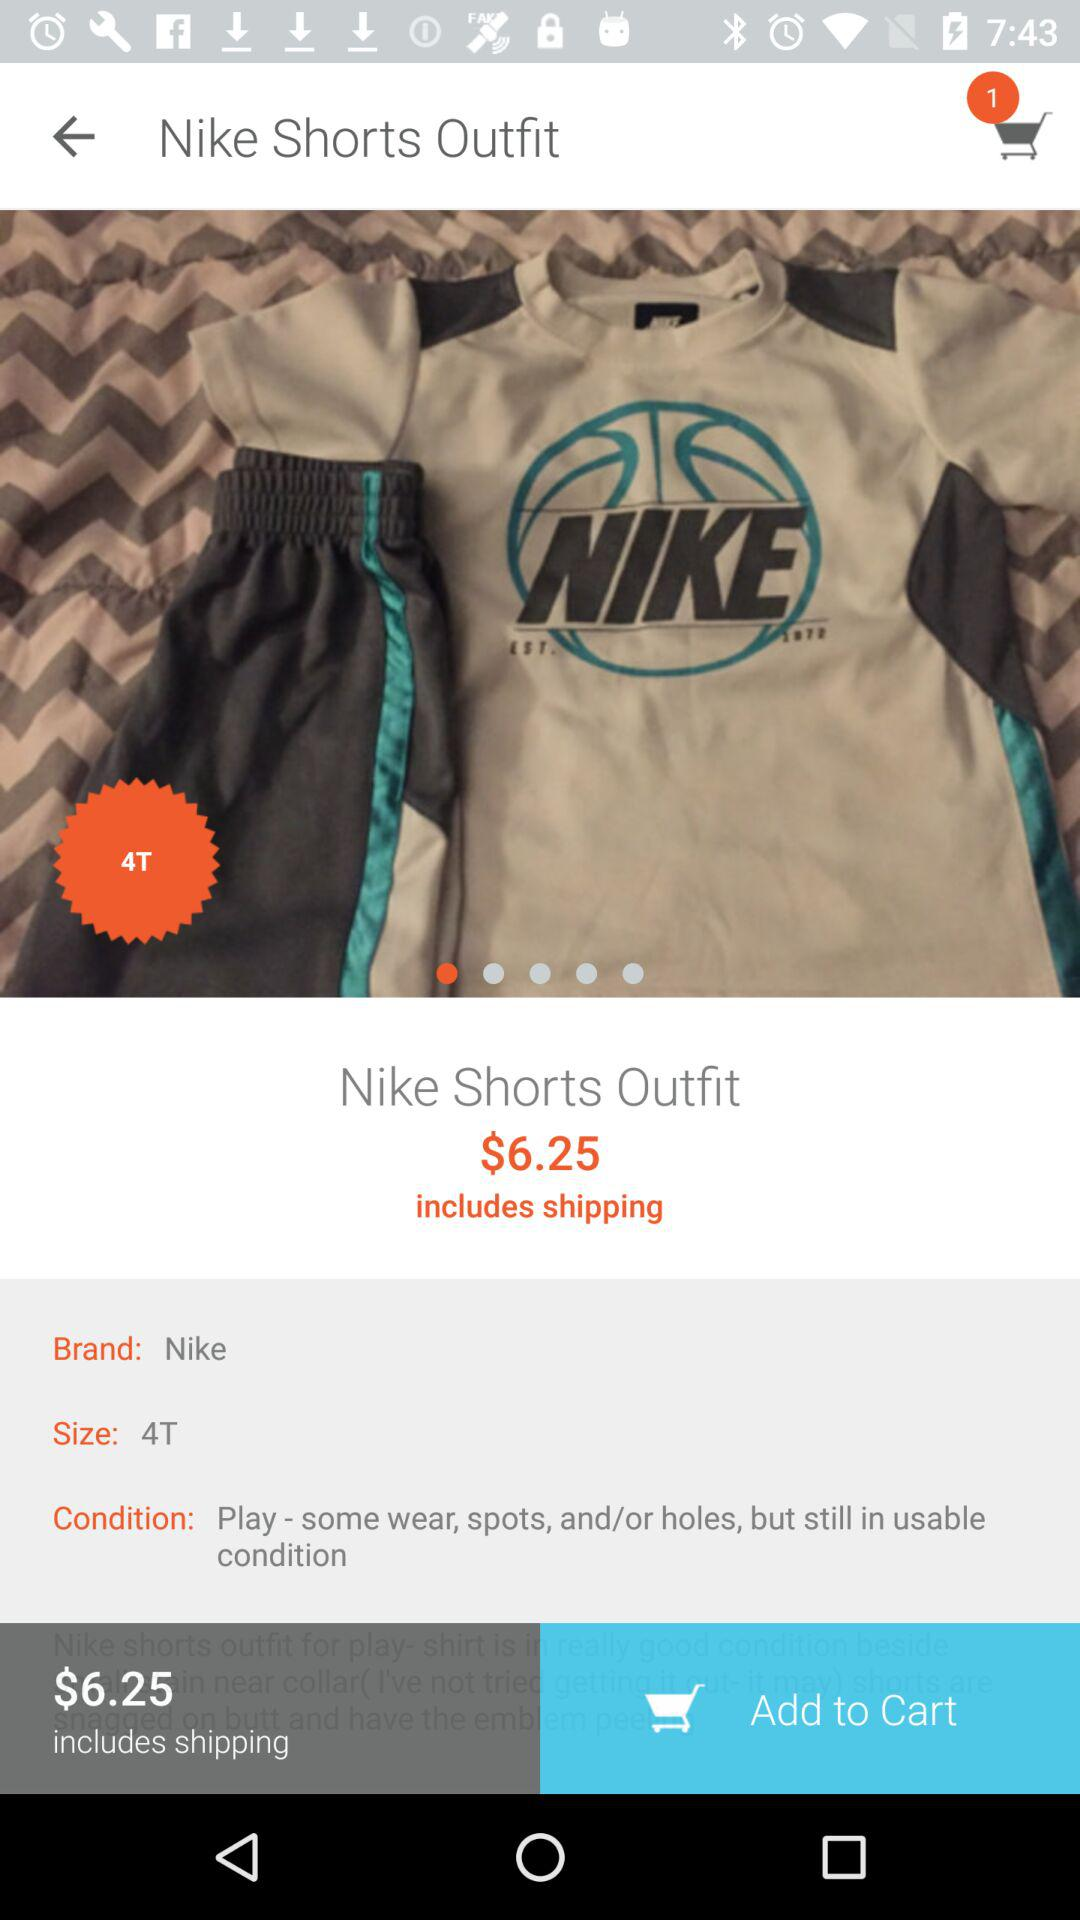What brand is it? It is "Nike" brand. 